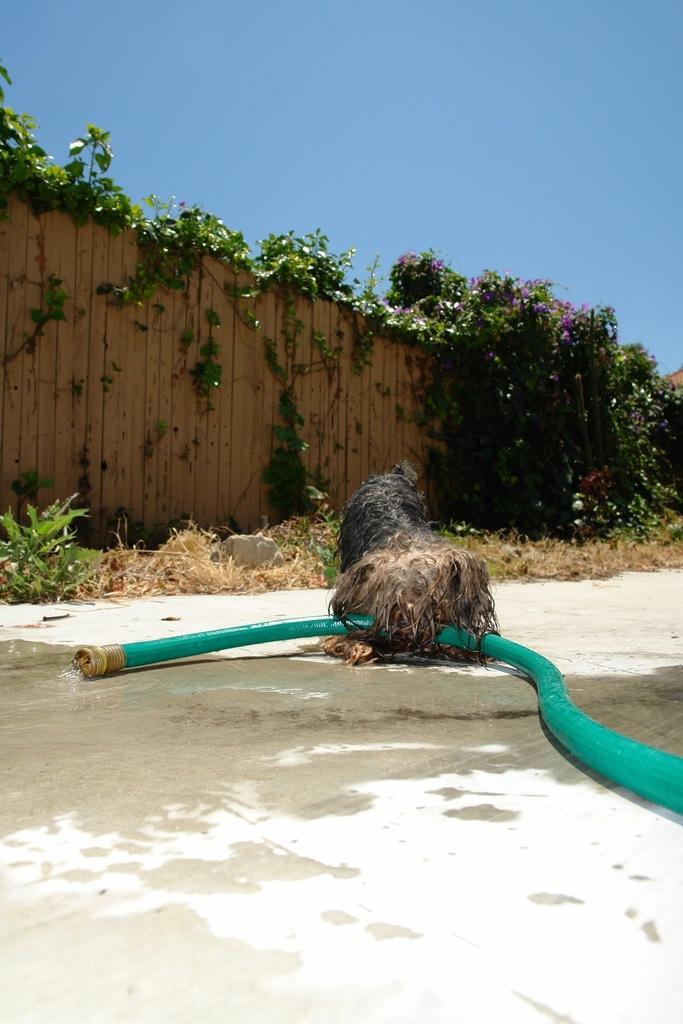How would you summarize this image in a sentence or two? In this image there is a pipe and a dog, in front of the dog there is grass on the surface, in front of the grass there is a wooden fence with some leaves on top of it. 